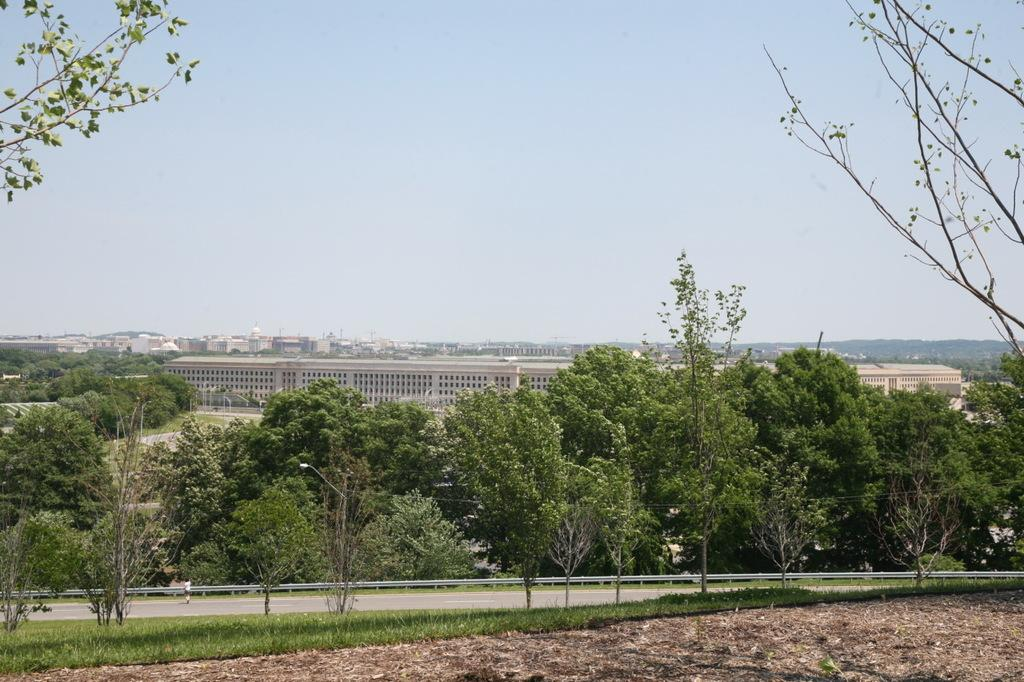What is the main feature in the center of the image? There is a sky in the center of the image. What type of structures can be seen in the image? There are buildings in the image. What type of vegetation is present in the image? Trees are present in the image. What type of barrier can be seen in the image? There are fences in the image. What type of ground surface is visible in the image? Grass is visible in the image. What type of vertical structures are present in the image? Poles are present in the image. What type of pathway is visible in the image? There is a road in the image. Are there any people visible in the image? Yes, one person is standing in the image. How many books can be seen on the patch in the image? There are no books or patches present in the image. 